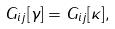Convert formula to latex. <formula><loc_0><loc_0><loc_500><loc_500>G _ { i j } [ \gamma ] = G _ { i j } [ \kappa ] ,</formula> 